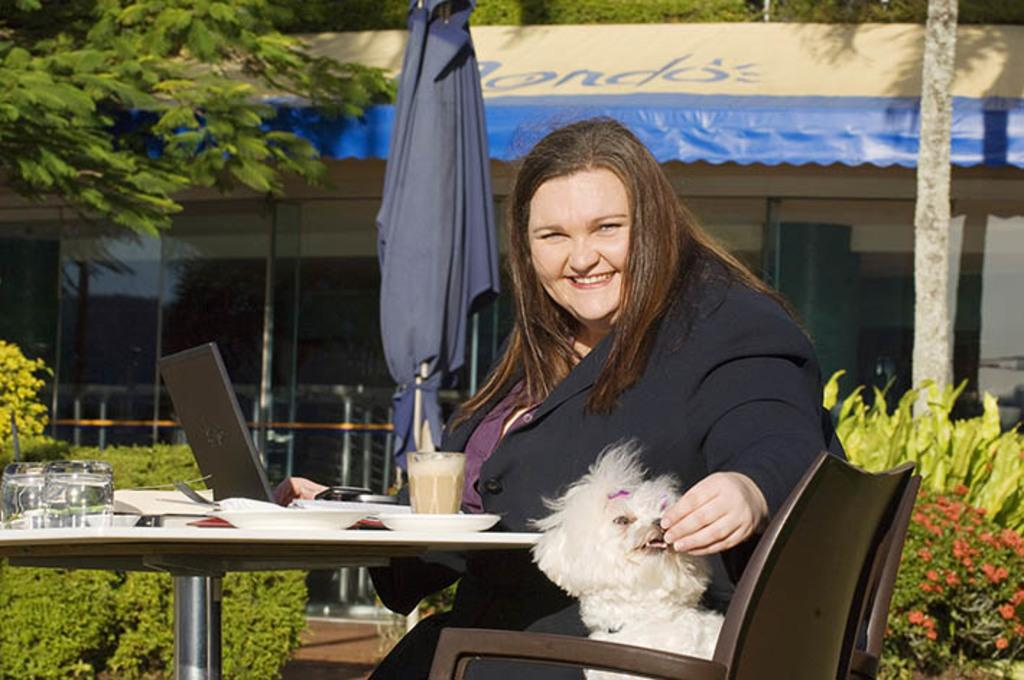What is the woman in the image doing? The woman is sitting in a chair and feeding a dog. Where are the trees located in the image? The trees are on the left side of the image. What can be seen through the windows in the image? The details of what can be seen through the windows are not provided in the facts, so we cannot answer that question definitively. What type of trousers is the woman wearing in the image? The facts provided do not mention the type of trousers the woman is wearing, so we cannot answer that question definitively. 